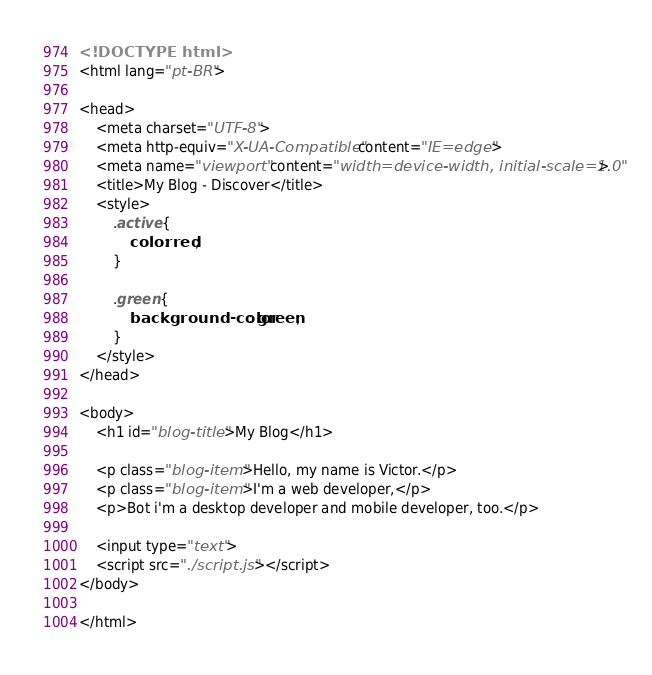Convert code to text. <code><loc_0><loc_0><loc_500><loc_500><_HTML_><!DOCTYPE html>
<html lang="pt-BR">

<head>
    <meta charset="UTF-8">
    <meta http-equiv="X-UA-Compatible" content="IE=edge">
    <meta name="viewport" content="width=device-width, initial-scale=1.0">
    <title>My Blog - Discover</title>
    <style>
        .active {
            color: red;
        }

        .green {
            background-color: green;
        }
    </style>
</head>

<body>
    <h1 id="blog-title">My Blog</h1>

    <p class="blog-item">Hello, my name is Victor.</p>
    <p class="blog-item">I'm a web developer,</p>
    <p>Bot i'm a desktop developer and mobile developer, too.</p>

    <input type="text">
    <script src="./script.js"></script>
</body>

</html></code> 